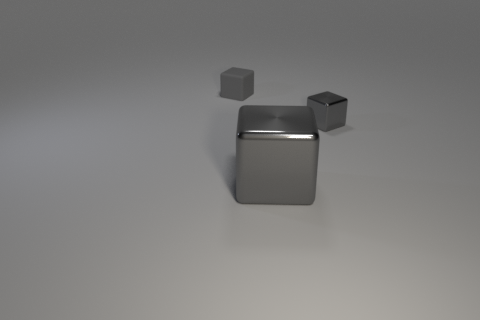Add 2 large brown matte objects. How many objects exist? 5 Subtract all large gray metal blocks. How many blocks are left? 2 Subtract 1 cubes. How many cubes are left? 2 Add 1 large gray blocks. How many large gray blocks exist? 2 Subtract 0 brown spheres. How many objects are left? 3 Subtract all yellow blocks. Subtract all yellow cylinders. How many blocks are left? 3 Subtract all small gray metallic blocks. Subtract all large gray metal blocks. How many objects are left? 1 Add 1 tiny metal cubes. How many tiny metal cubes are left? 2 